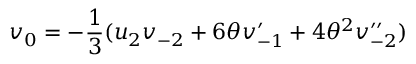<formula> <loc_0><loc_0><loc_500><loc_500>v _ { 0 } = - \frac { 1 } { 3 } ( u _ { 2 } v _ { - 2 } + 6 \theta v _ { - 1 } ^ { \prime } + 4 { \theta } ^ { 2 } v _ { - 2 } ^ { \prime \prime } )</formula> 